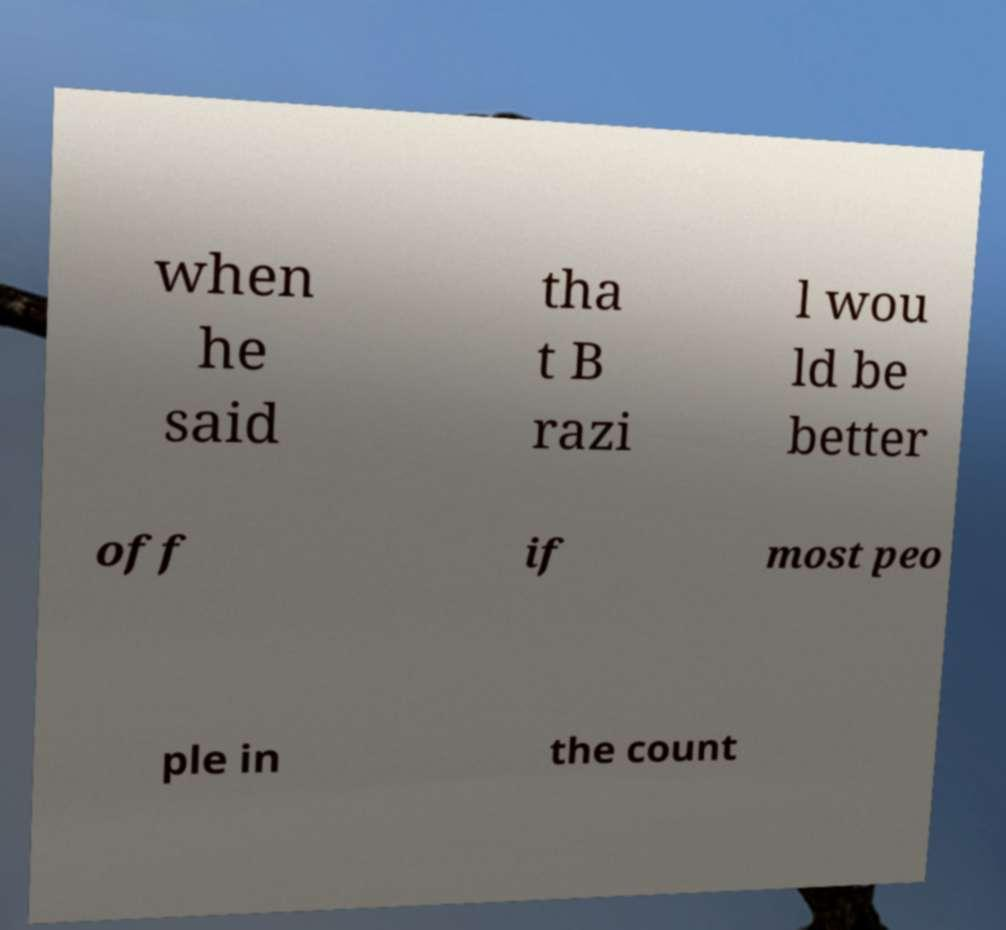For documentation purposes, I need the text within this image transcribed. Could you provide that? when he said tha t B razi l wou ld be better off if most peo ple in the count 